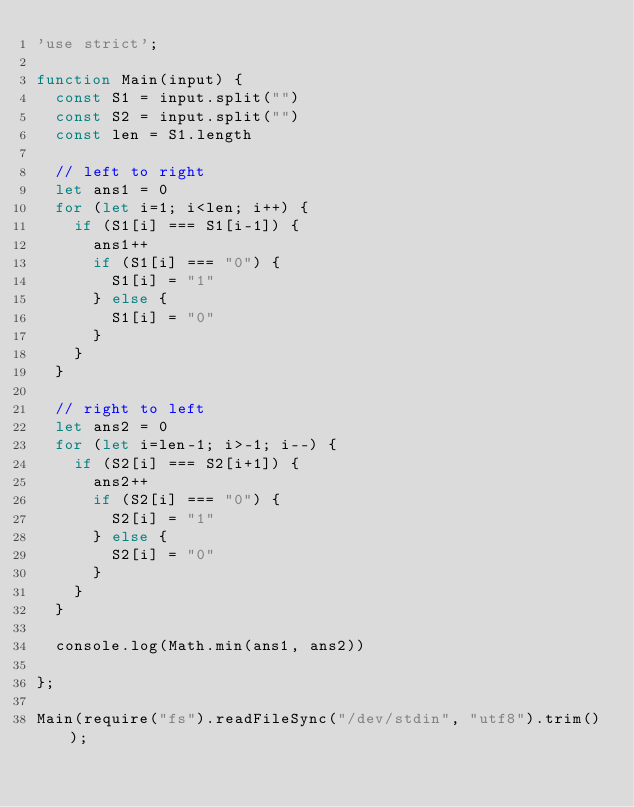Convert code to text. <code><loc_0><loc_0><loc_500><loc_500><_JavaScript_>'use strict';

function Main(input) {
  const S1 = input.split("")
  const S2 = input.split("")
  const len = S1.length
  
  // left to right
  let ans1 = 0
  for (let i=1; i<len; i++) {
    if (S1[i] === S1[i-1]) {
      ans1++
      if (S1[i] === "0") {
        S1[i] = "1"
      } else {
        S1[i] = "0"
      }
    }
  }

  // right to left
  let ans2 = 0
  for (let i=len-1; i>-1; i--) {
    if (S2[i] === S2[i+1]) {
      ans2++
      if (S2[i] === "0") {
        S2[i] = "1"
      } else {
        S2[i] = "0"
      }
    }
  }

  console.log(Math.min(ans1, ans2))

};

Main(require("fs").readFileSync("/dev/stdin", "utf8").trim());
</code> 